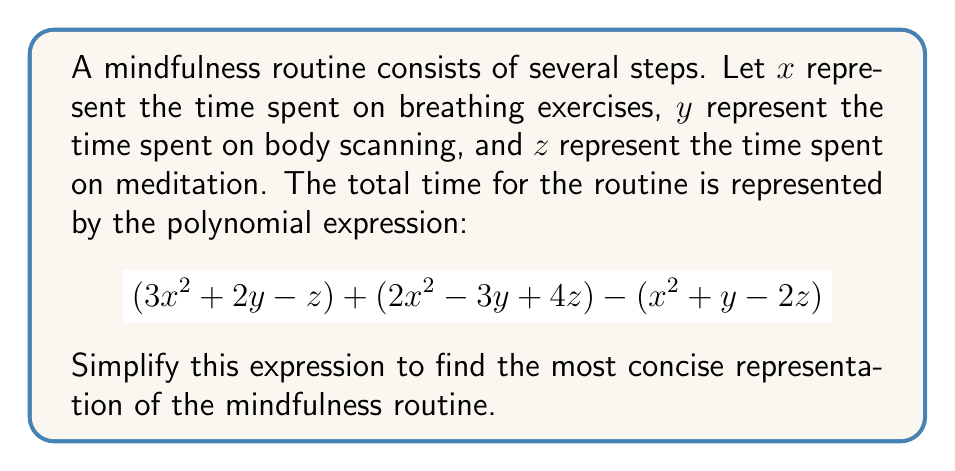Give your solution to this math problem. To simplify this polynomial expression, we need to combine like terms. Let's break it down step-by-step:

1) First, let's identify the like terms in the expression:
   $$(3x^2 + 2y - z) + (2x^2 - 3y + 4z) - (x^2 + y - 2z)$$
   
   We have $x^2$ terms, $y$ terms, and $z$ terms.

2) Let's group the $x^2$ terms:
   $3x^2 + 2x^2 - x^2 = 4x^2$

3) Now, let's group the $y$ terms:
   $2y - 3y - y = -2y$

4) Finally, let's group the $z$ terms:
   $-z + 4z + 2z = 5z$

5) Combining these simplified terms, we get:
   $$4x^2 - 2y + 5z$$

This simplified expression represents the most concise form of the polynomial representing the mindfulness routine.
Answer: $4x^2 - 2y + 5z$ 